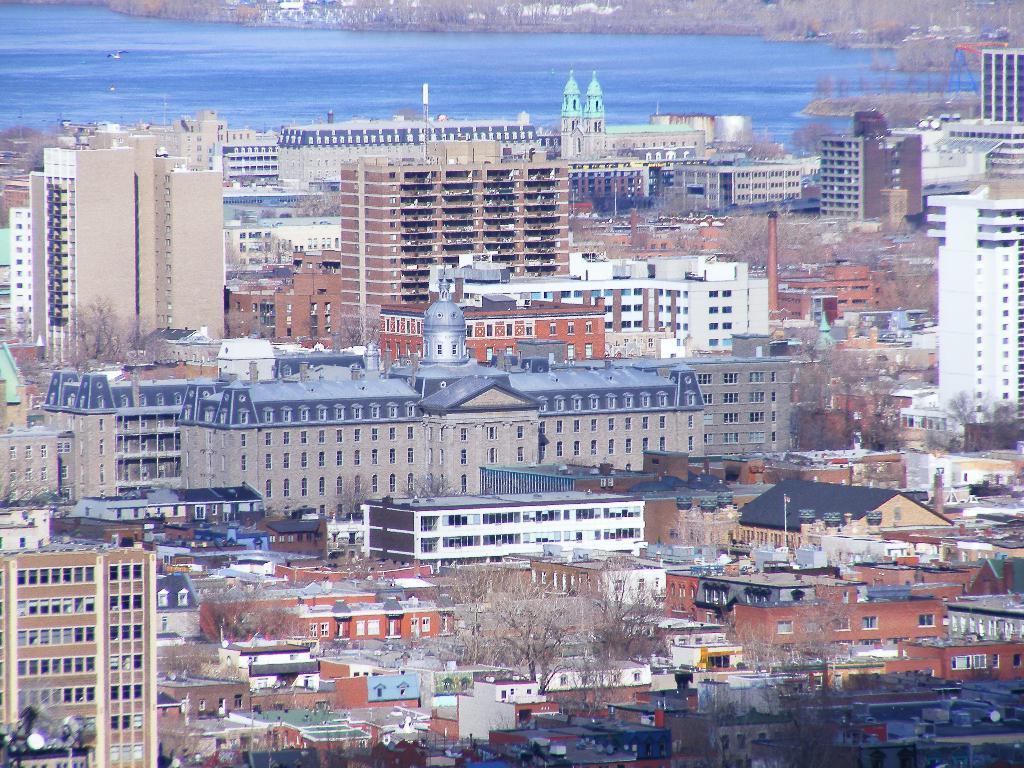Please provide a concise description of this image. In this image there are so many building and some trees at the middle, behind them there is a lake. 